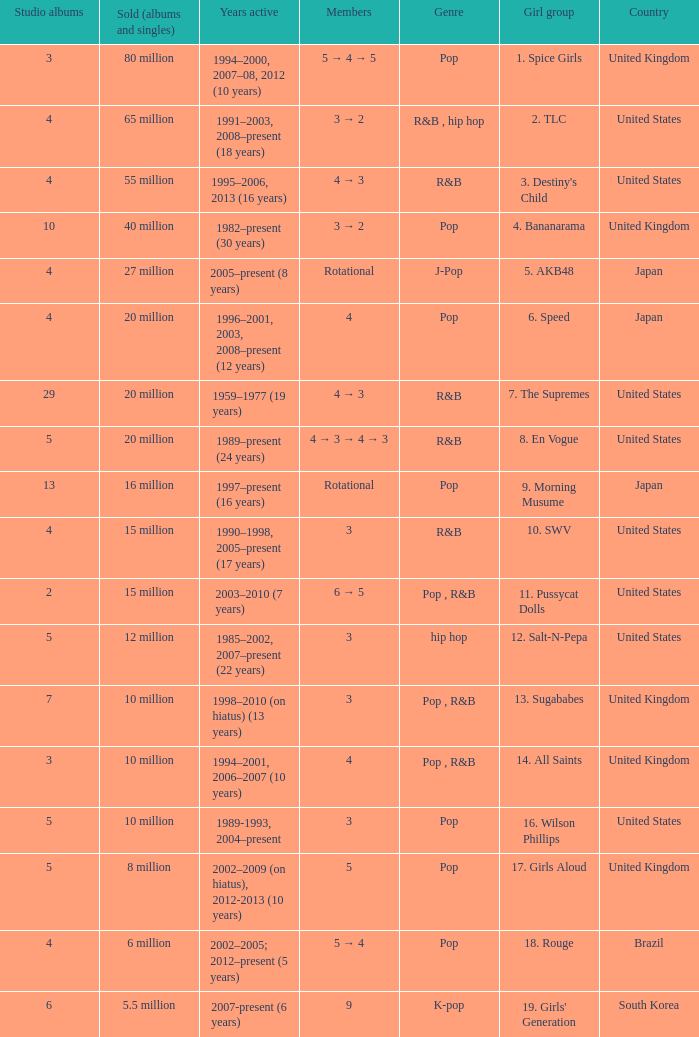How many members were in the group that sold 65 million albums and singles? 3 → 2. 